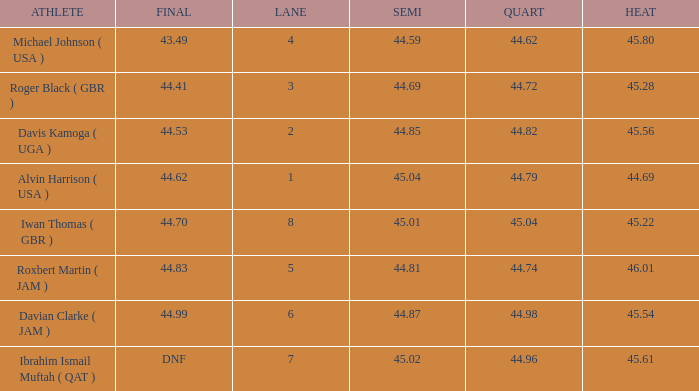62, what is the lowest heat? None. 